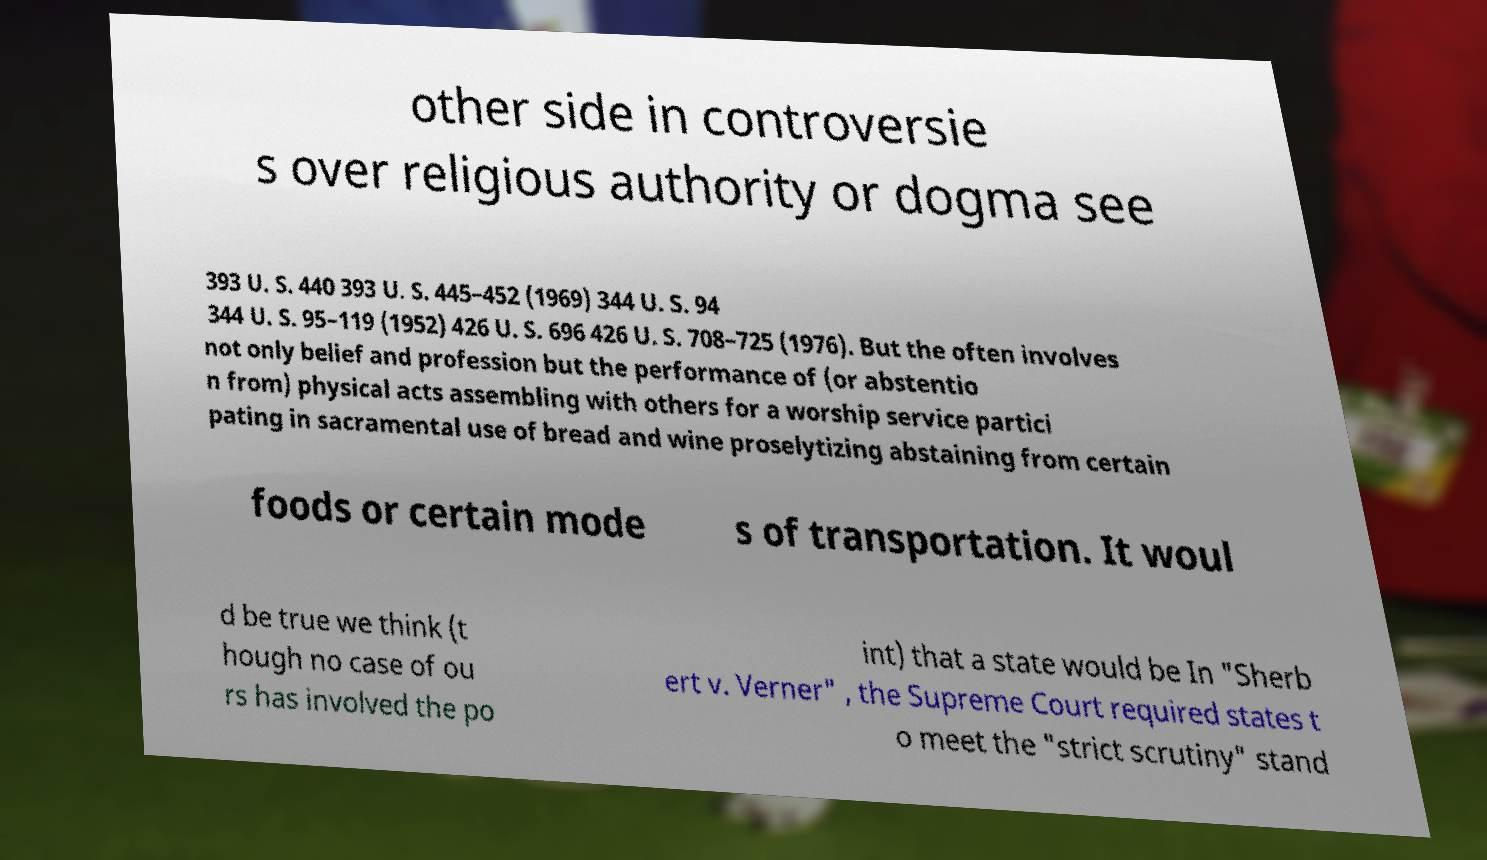Can you read and provide the text displayed in the image?This photo seems to have some interesting text. Can you extract and type it out for me? other side in controversie s over religious authority or dogma see 393 U. S. 440 393 U. S. 445–452 (1969) 344 U. S. 94 344 U. S. 95–119 (1952) 426 U. S. 696 426 U. S. 708–725 (1976). But the often involves not only belief and profession but the performance of (or abstentio n from) physical acts assembling with others for a worship service partici pating in sacramental use of bread and wine proselytizing abstaining from certain foods or certain mode s of transportation. It woul d be true we think (t hough no case of ou rs has involved the po int) that a state would be In "Sherb ert v. Verner" , the Supreme Court required states t o meet the "strict scrutiny" stand 